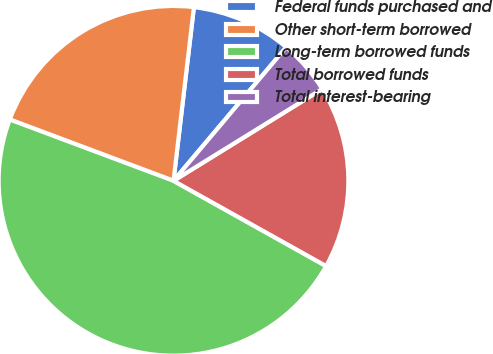Convert chart to OTSL. <chart><loc_0><loc_0><loc_500><loc_500><pie_chart><fcel>Federal funds purchased and<fcel>Other short-term borrowed<fcel>Long-term borrowed funds<fcel>Total borrowed funds<fcel>Total interest-bearing<nl><fcel>9.29%<fcel>21.16%<fcel>47.59%<fcel>16.91%<fcel>5.04%<nl></chart> 